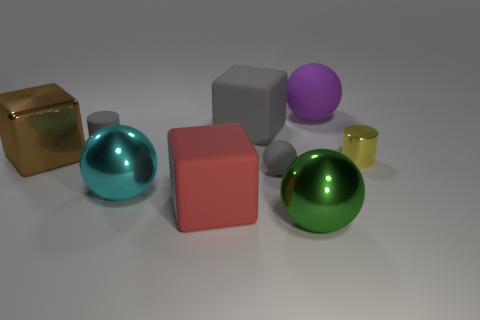Subtract all brown metal cubes. How many cubes are left? 2 Subtract all red blocks. How many blocks are left? 2 Subtract all balls. How many objects are left? 5 Subtract all red balls. Subtract all green blocks. How many balls are left? 4 Subtract all purple balls. Subtract all purple shiny objects. How many objects are left? 8 Add 3 gray matte cubes. How many gray matte cubes are left? 4 Add 3 small green cylinders. How many small green cylinders exist? 3 Subtract 1 purple balls. How many objects are left? 8 Subtract 2 spheres. How many spheres are left? 2 